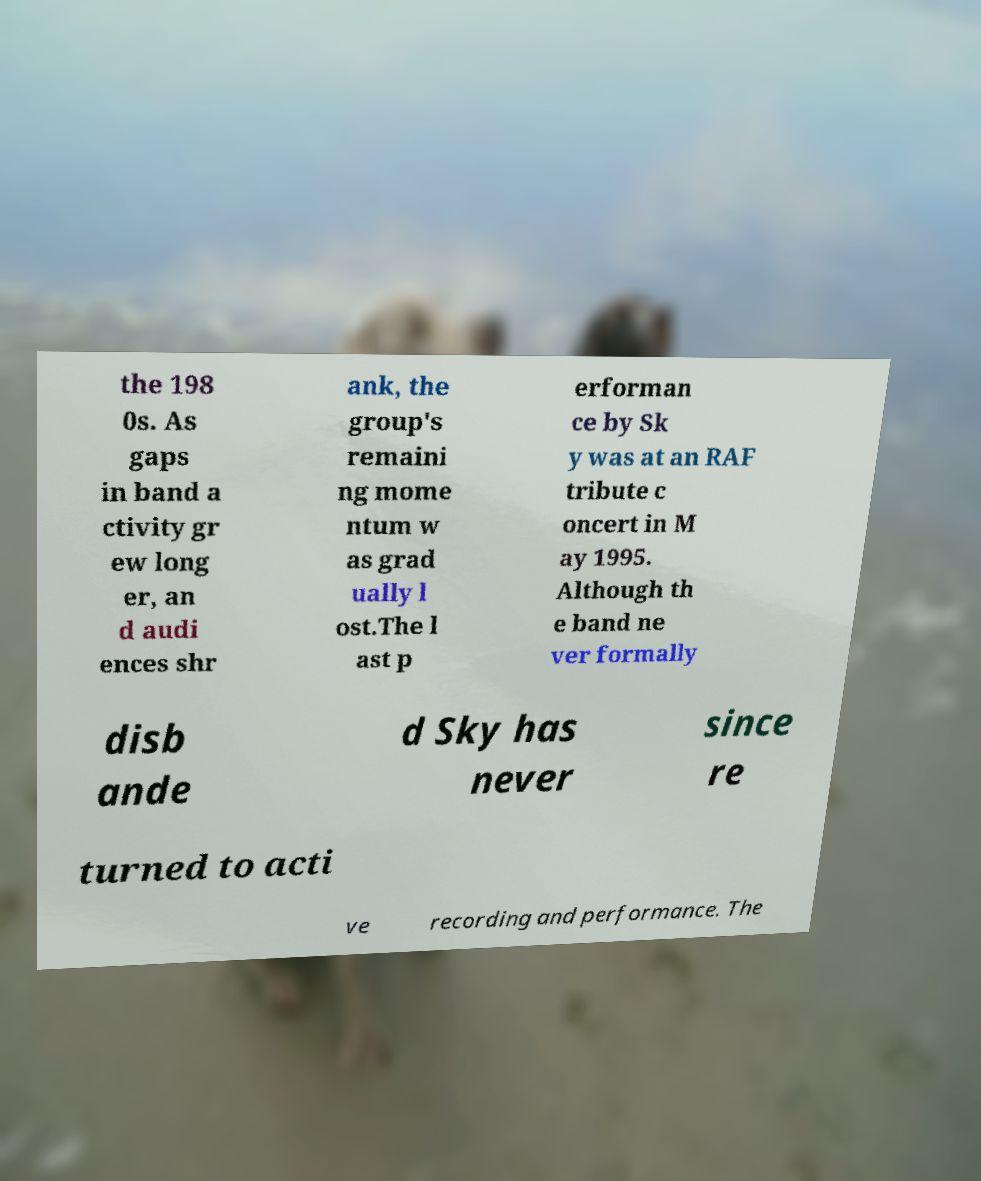Could you extract and type out the text from this image? the 198 0s. As gaps in band a ctivity gr ew long er, an d audi ences shr ank, the group's remaini ng mome ntum w as grad ually l ost.The l ast p erforman ce by Sk y was at an RAF tribute c oncert in M ay 1995. Although th e band ne ver formally disb ande d Sky has never since re turned to acti ve recording and performance. The 